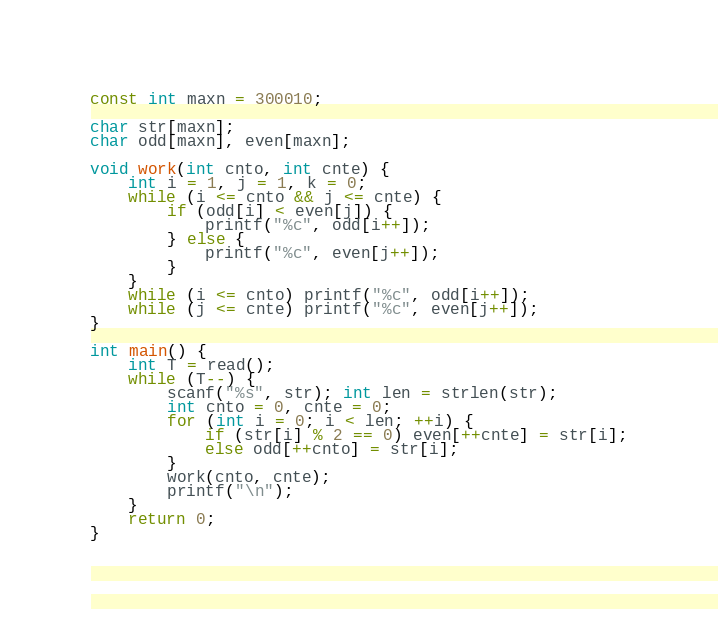<code> <loc_0><loc_0><loc_500><loc_500><_C++_>
const int maxn = 300010;

char str[maxn];
char odd[maxn], even[maxn];

void work(int cnto, int cnte) {
    int i = 1, j = 1, k = 0;
    while (i <= cnto && j <= cnte) {
        if (odd[i] < even[j]) {
            printf("%c", odd[i++]);
        } else {
            printf("%c", even[j++]);
        }
    }
    while (i <= cnto) printf("%c", odd[i++]);
    while (j <= cnte) printf("%c", even[j++]);
}

int main() {
    int T = read();
    while (T--) {
        scanf("%s", str); int len = strlen(str);
        int cnto = 0, cnte = 0;
        for (int i = 0; i < len; ++i) {
            if (str[i] % 2 == 0) even[++cnte] = str[i];
            else odd[++cnto] = str[i];
        }
        work(cnto, cnte);
        printf("\n");
    }
    return 0;
}</code> 